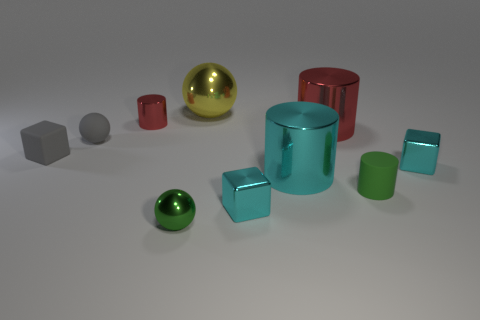How would you describe the arrangement of these objects? The objects are arranged in a seemingly random fashion across a flat surface, presenting a variety of shapes, sizes, and materials that could represent a study in geometry and reflections. 